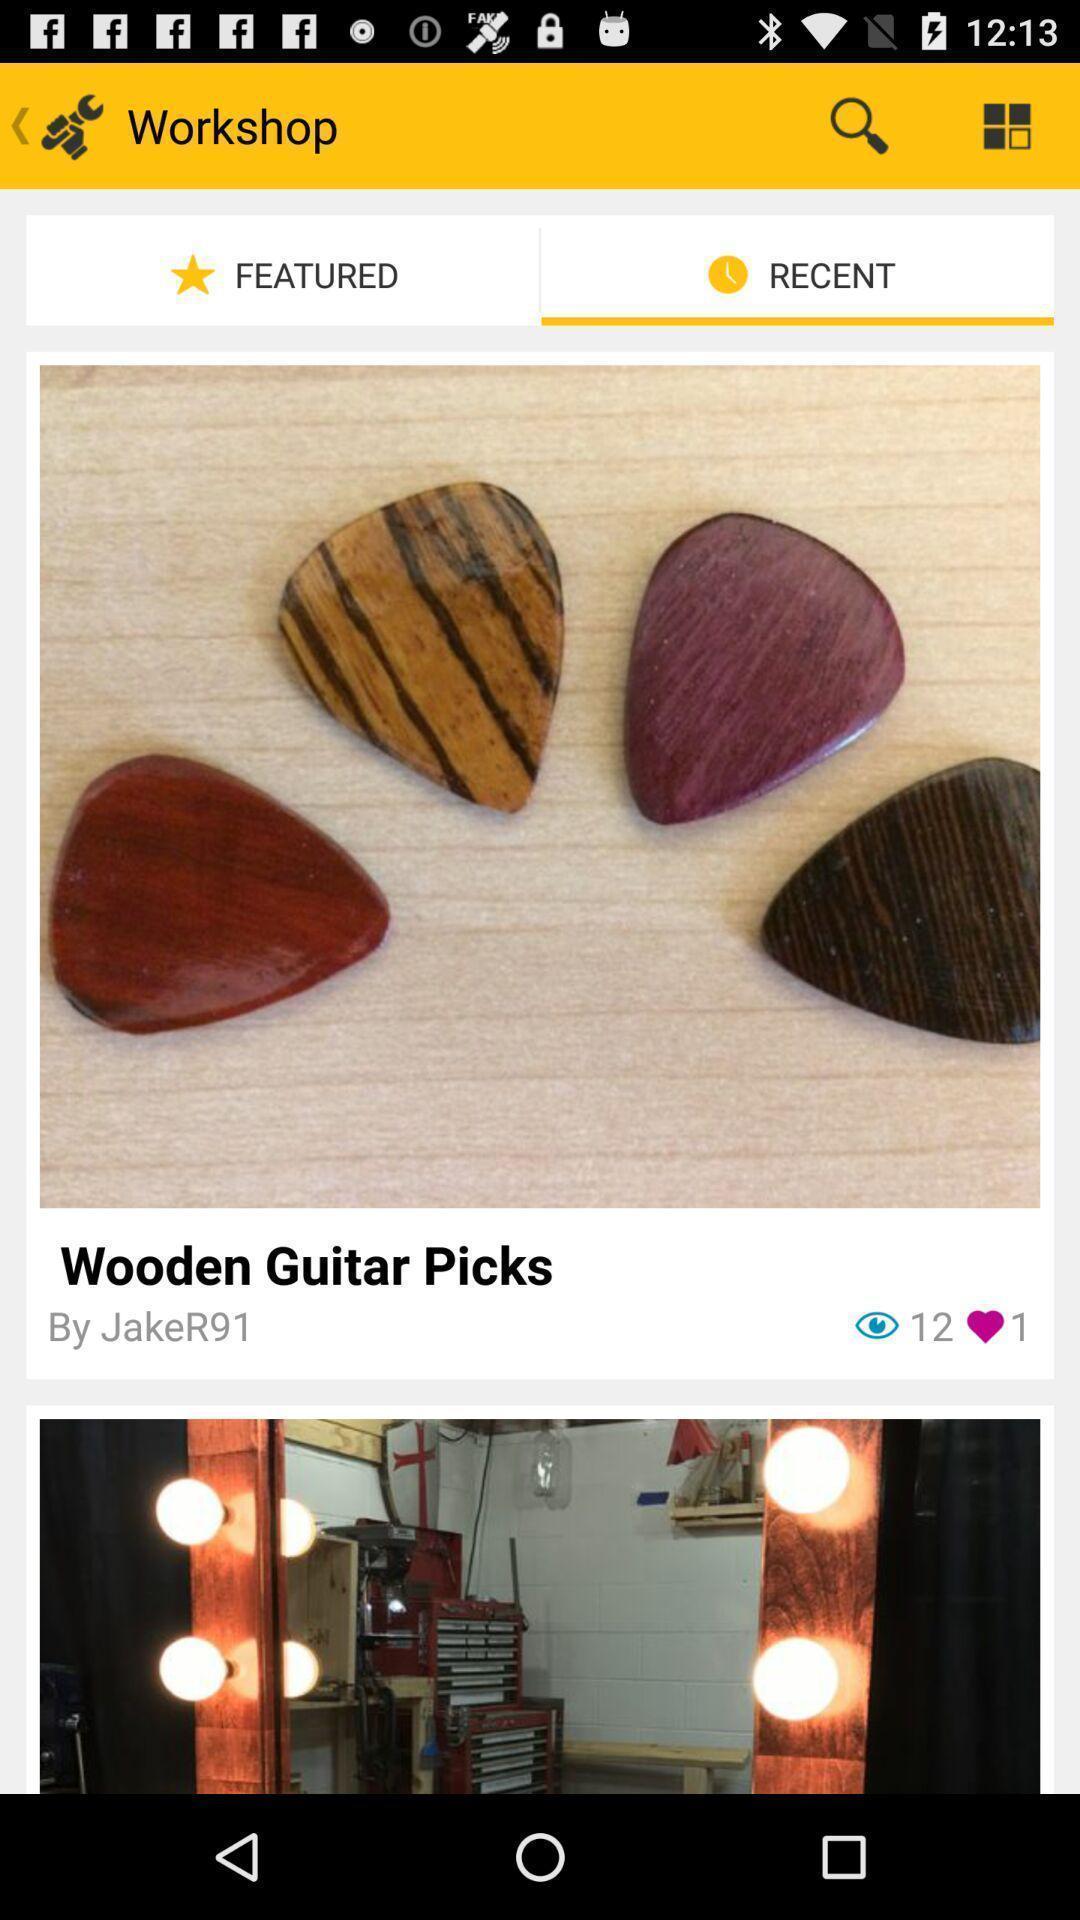Summarize the information in this screenshot. Page showing recent workshops in learning new skills app. 